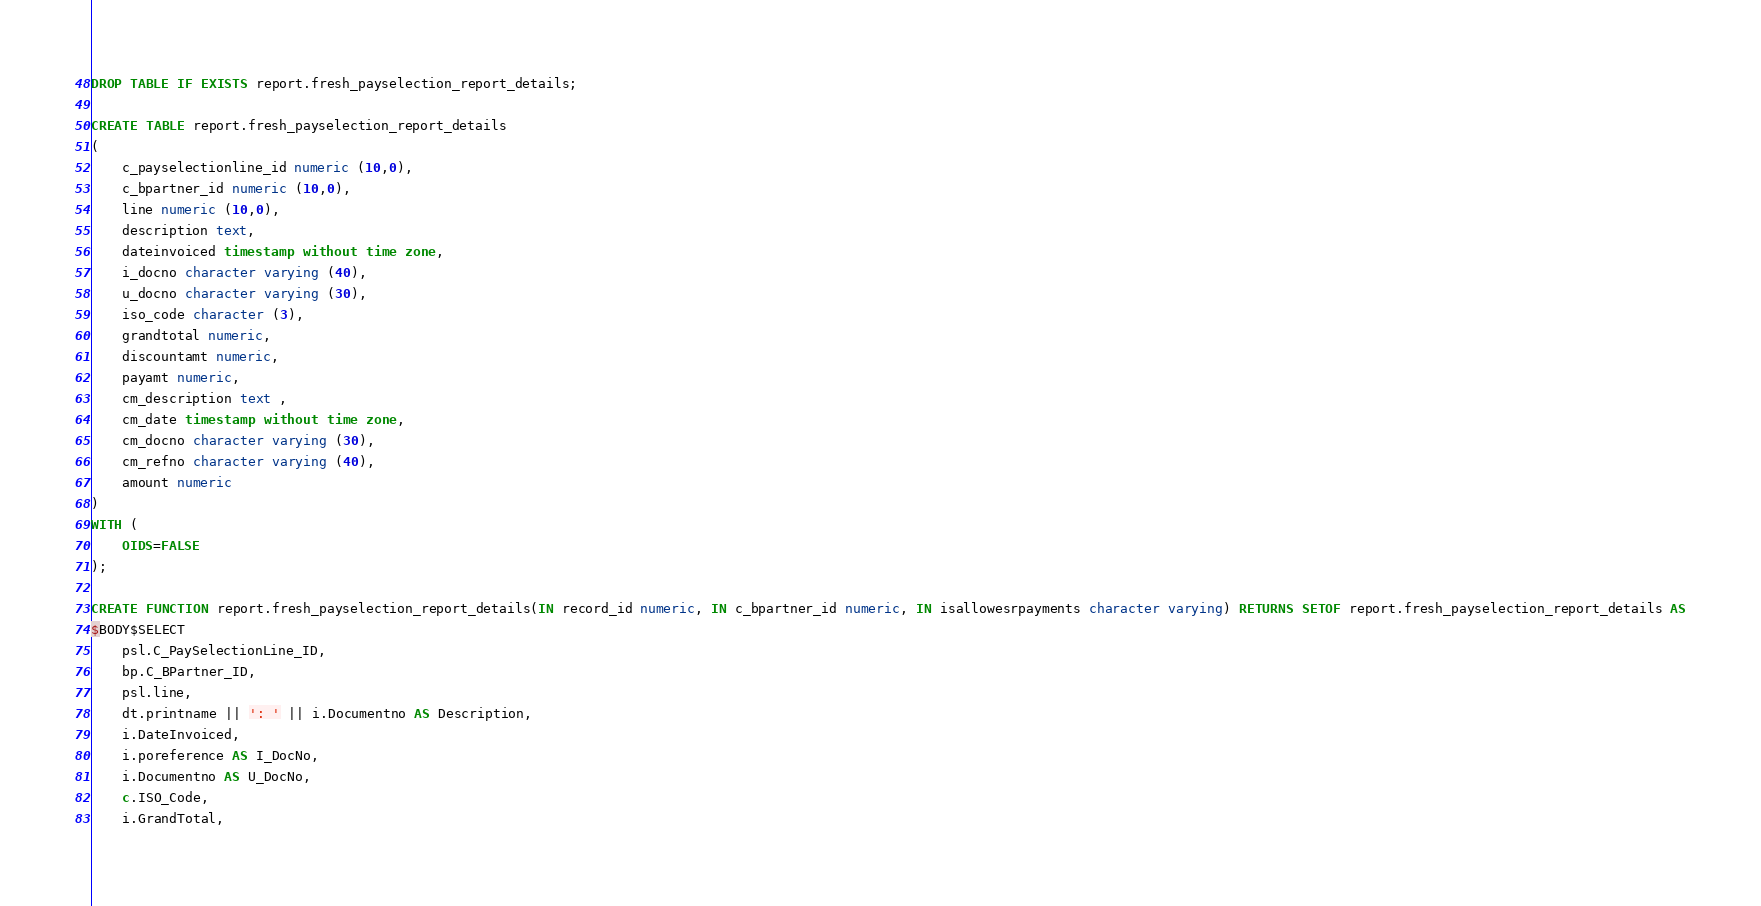Convert code to text. <code><loc_0><loc_0><loc_500><loc_500><_SQL_>DROP TABLE IF EXISTS report.fresh_payselection_report_details;

CREATE TABLE report.fresh_payselection_report_details
(
	c_payselectionline_id numeric (10,0), 
	c_bpartner_id numeric (10,0),
	line numeric (10,0),
	description text,
	dateinvoiced timestamp without time zone,
	i_docno character varying (40),
	u_docno character varying (30),
	iso_code character (3),
	grandtotal numeric,
	discountamt numeric,
	payamt numeric,
	cm_description text ,
	cm_date timestamp without time zone,
	cm_docno character varying (30),
	cm_refno character varying (40),
	amount numeric
)
WITH (
	OIDS=FALSE
);

CREATE FUNCTION report.fresh_payselection_report_details(IN record_id numeric, IN c_bpartner_id numeric, IN isallowesrpayments character varying) RETURNS SETOF report.fresh_payselection_report_details AS
$BODY$SELECT
	psl.C_PaySelectionLine_ID,
	bp.C_BPartner_ID,
	psl.line,
	dt.printname || ': ' || i.Documentno AS Description,
	i.DateInvoiced,
	i.poreference AS I_DocNo,
	i.Documentno AS U_DocNo,
	c.ISO_Code,
	i.GrandTotal,</code> 